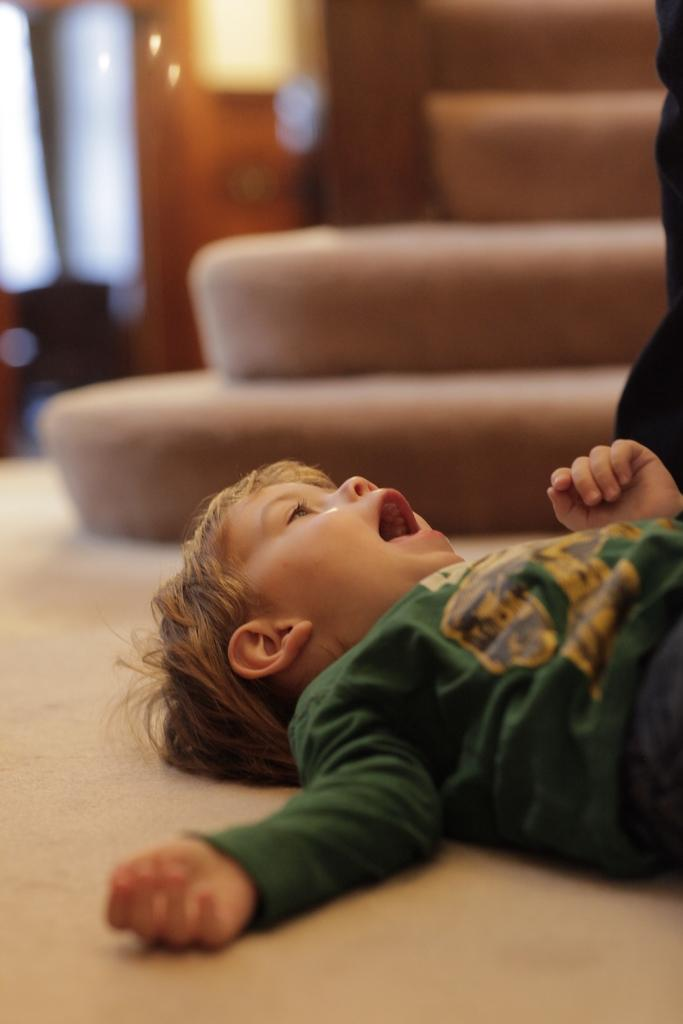What is the main subject of the image? The main subject of the image is a kid. What is the kid doing in the image? The kid is lying on the floor. How does the kid's underwear contribute to the overall theme of the image? There is no mention of underwear in the image, so it cannot contribute to the overall theme. 